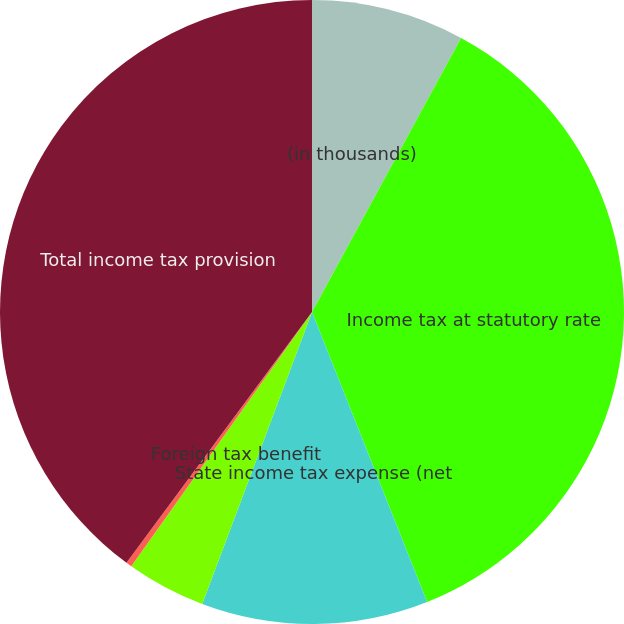Convert chart to OTSL. <chart><loc_0><loc_0><loc_500><loc_500><pie_chart><fcel>(in thousands)<fcel>Income tax at statutory rate<fcel>State income tax expense (net<fcel>Foreign tax benefit<fcel>Other<fcel>Total income tax provision<nl><fcel>7.93%<fcel>36.06%<fcel>11.74%<fcel>4.11%<fcel>0.3%<fcel>39.87%<nl></chart> 